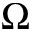<formula> <loc_0><loc_0><loc_500><loc_500>\Omega</formula> 